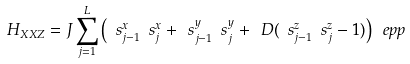<formula> <loc_0><loc_0><loc_500><loc_500>H _ { X X Z } = J \sum _ { j = 1 } ^ { L } \left ( \ s _ { j - 1 } ^ { x } \ s _ { j } ^ { x } + \ s _ { j - 1 } ^ { y } \ s _ { j } ^ { y } + \ D ( \ s _ { j - 1 } ^ { z } \ s _ { j } ^ { z } - 1 ) \right ) \ e p p</formula> 